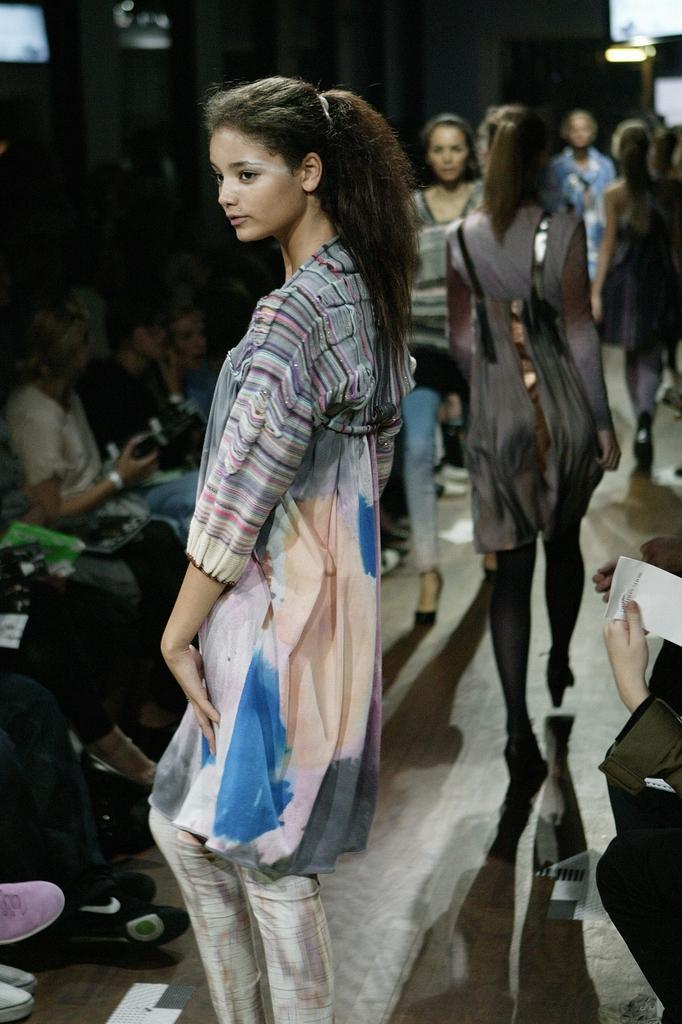What is the lady in the image doing? There is a lady standing in the image. What can be seen happening in the background of the image? There are people walking in the background of the image. What are some of the other people in the image doing? There are people sitting in the image. Can you describe the activity of the person on the right side of the image? A person on the right side of the image is holding a paper. What type of horn is the lady holding in the image? There is no horn present in the image; the lady is standing without any visible objects. 